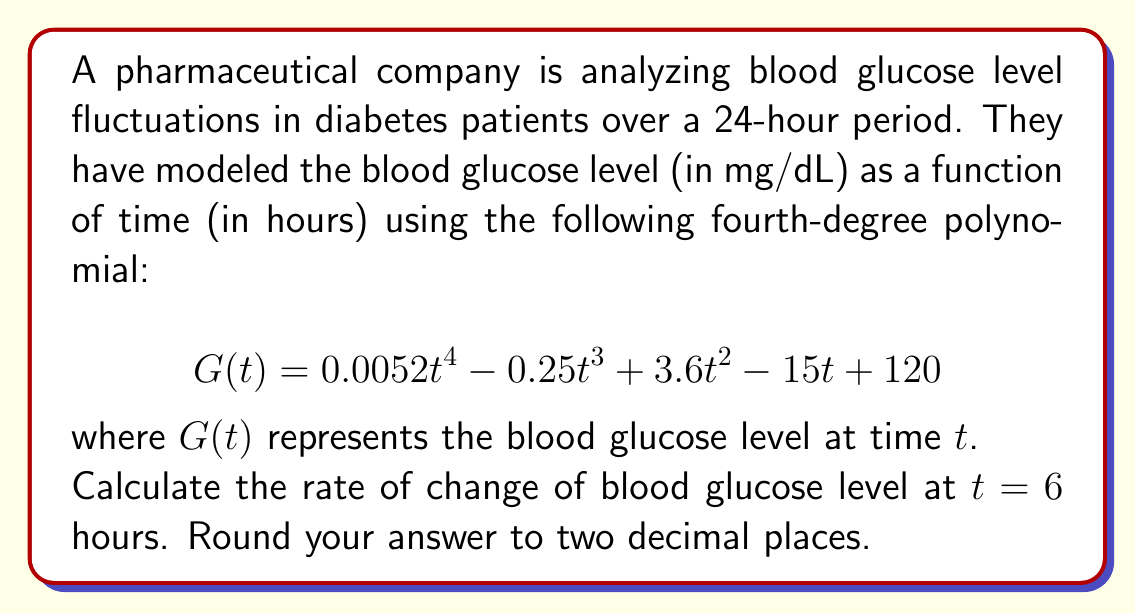Provide a solution to this math problem. To find the rate of change of blood glucose level at $t = 6$ hours, we need to calculate the first derivative of the function $G(t)$ and then evaluate it at $t = 6$.

1. First, let's find the derivative of $G(t)$:

   $$G(t) = 0.0052t^4 - 0.25t^3 + 3.6t^2 - 15t + 120$$
   $$G'(t) = 4(0.0052)t^3 - 3(0.25)t^2 + 2(3.6)t - 15$$
   $$G'(t) = 0.0208t^3 - 0.75t^2 + 7.2t - 15$$

2. Now, we evaluate $G'(t)$ at $t = 6$:

   $$G'(6) = 0.0208(6^3) - 0.75(6^2) + 7.2(6) - 15$$
   $$G'(6) = 0.0208(216) - 0.75(36) + 7.2(6) - 15$$
   $$G'(6) = 4.4928 - 27 + 43.2 - 15$$
   $$G'(6) = 5.6928$$

3. Rounding to two decimal places:

   $$G'(6) \approx 5.69$$
Answer: 5.69 mg/dL per hour 